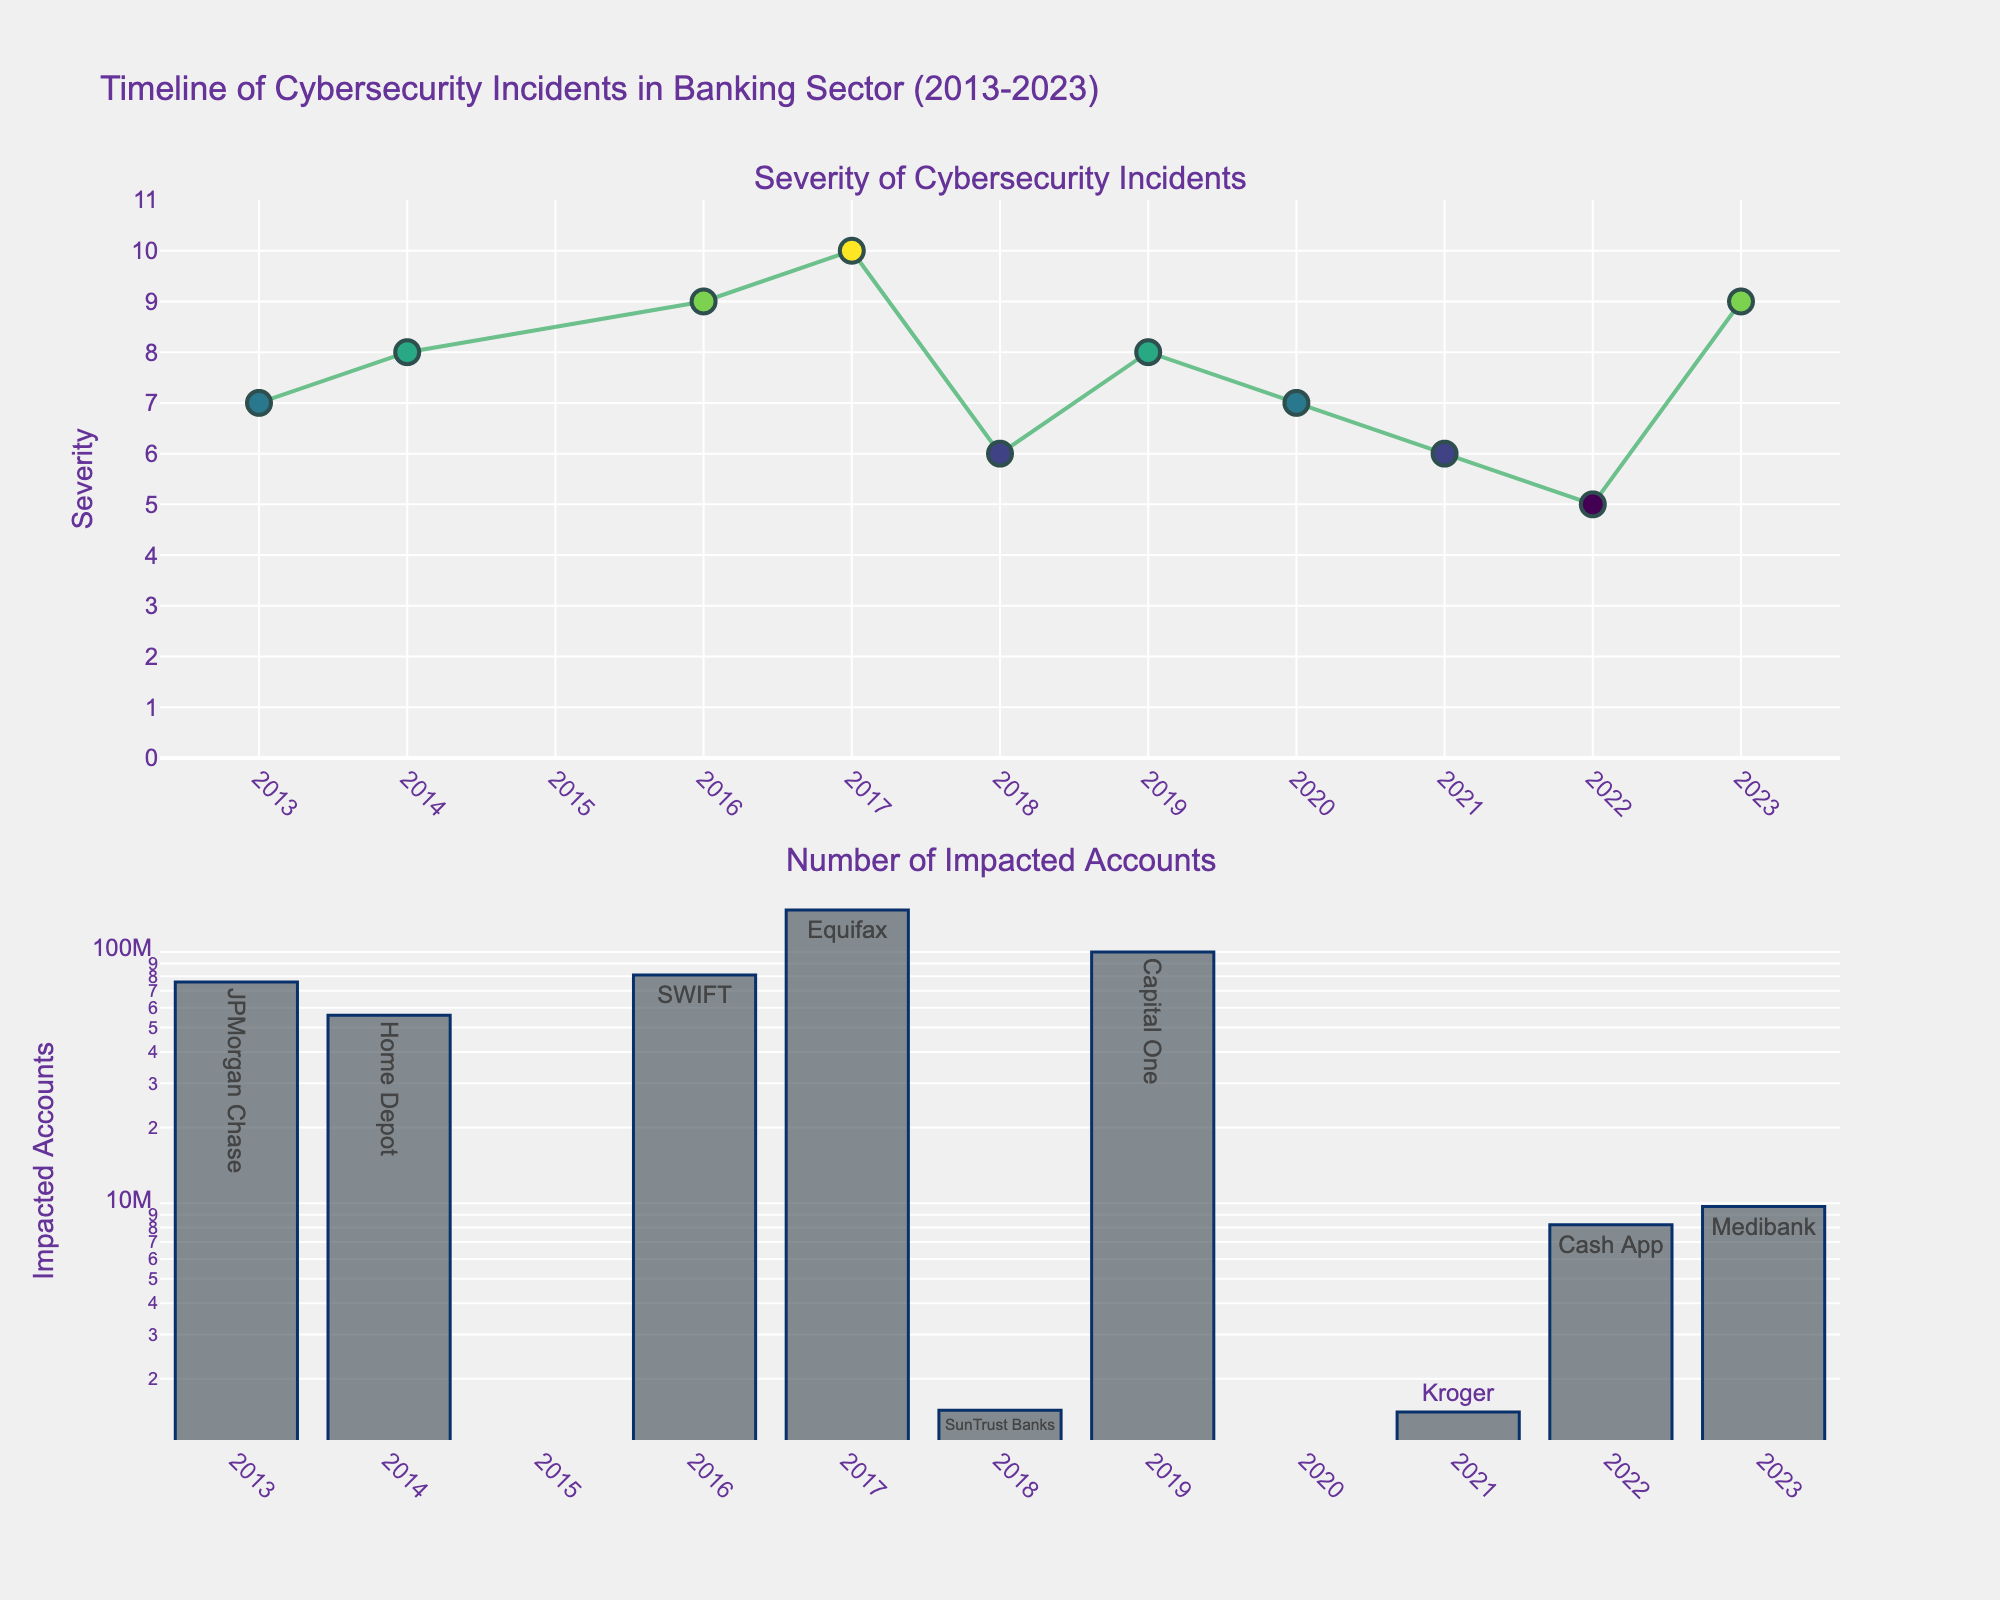Which price range has the highest market share for Bose? The figure has multiple subplots representing different price ranges. By looking at the bars for Bose, the highest market share percentage appears under $100-$300.
Answer: $100-$300 Among the brands listed, which one has the highest market share in the $500-$1000 range? By examining the $500-$1000 subplot, the bar with the highest percentage stands for Sonos with 35%.
Answer: Sonos What is the combined market share of Bose and Sony in the under $100 range? By looking at the respective bars for Bose (25%) and Sony (30%) in the under $100 subplot, we sum them: 25% + 30%.
Answer: 55% Which brand has the lowest market share in the over $1000 range? In the over $1000 subplot, the smallest bar corresponds to Sony with 5%.
Answer: Sony How does the market share of custom systems change as the price range increases? Observing the bars for custom systems across subplots, they increase from 10% to 5%, 10%, 15%, and 30% as the price range increases.
Answer: Increases Compare the market shares of JBL and Harman Kardon in the $100-$300 range. Which is higher? Looking at the $100-$300 subplot, JBL has a market share of 15% while Harman Kardon has 10%. 15% is higher than 10%.
Answer: JBL Which brand shows a consistent decrease in market share as the price range increases? Examining the subplots, Sony's bars show a consistent decrease: 30%, 25%, 15%, 10%, and 5%.
Answer: Sony In which price range does Sonos have the highest market share? By analyzing the subplots, the highest bar for Sonos is in the $500-$1000 price range with a 35% share.
Answer: $500-$1000 Summarize the market share trend for Harman Kardon across price ranges. The market share of Harman Kardon starts at 10%, remains the same at $100-$300, increases to 15% at $300-$500, 20% at $500-$1000, and 25% over $1000.
Answer: Increasing Comparing Bose in the under $100 range and in the over $1000 range, which range shows a greater market share? In the under $100 range, the market share for Bose is 25%; in the over $1000 range, it's 10%. 25% is greater than 10%.
Answer: Under $100 